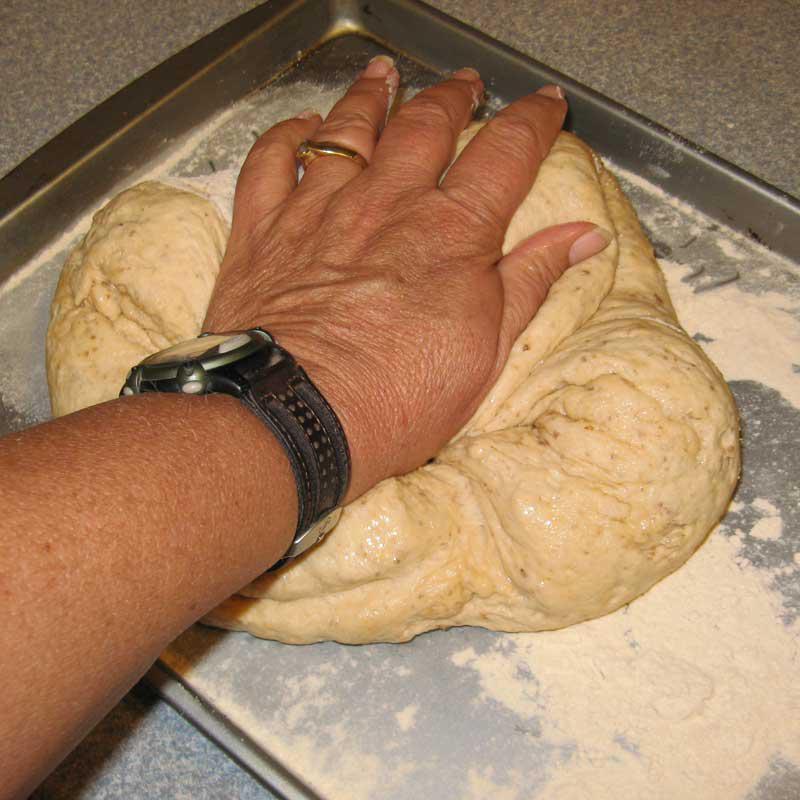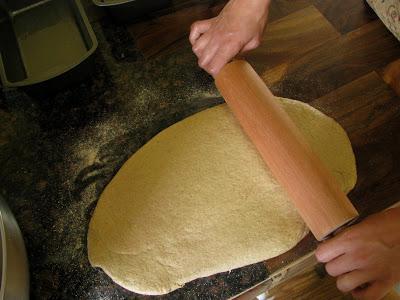The first image is the image on the left, the second image is the image on the right. Evaluate the accuracy of this statement regarding the images: "The right image shows a pair of hands with fingers touching flattened dough on floured wood,". Is it true? Answer yes or no. No. The first image is the image on the left, the second image is the image on the right. Evaluate the accuracy of this statement regarding the images: "There are no wooden utensils present.". Is it true? Answer yes or no. No. 